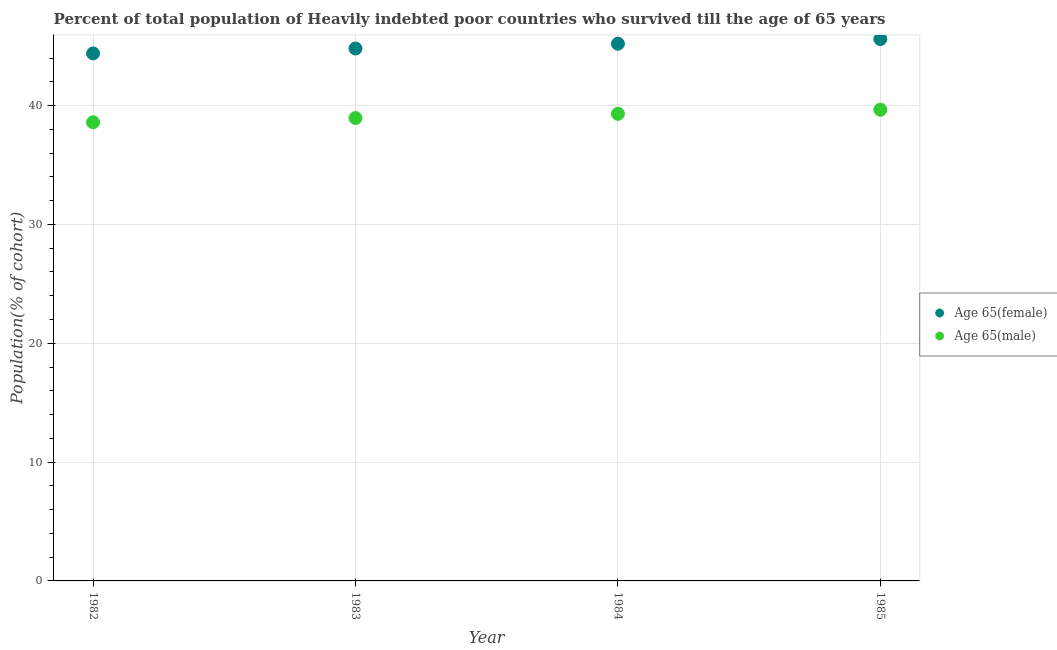How many different coloured dotlines are there?
Make the answer very short. 2. Is the number of dotlines equal to the number of legend labels?
Give a very brief answer. Yes. What is the percentage of male population who survived till age of 65 in 1982?
Ensure brevity in your answer.  38.6. Across all years, what is the maximum percentage of male population who survived till age of 65?
Offer a very short reply. 39.66. Across all years, what is the minimum percentage of male population who survived till age of 65?
Keep it short and to the point. 38.6. What is the total percentage of female population who survived till age of 65 in the graph?
Provide a short and direct response. 180.02. What is the difference between the percentage of female population who survived till age of 65 in 1983 and that in 1985?
Offer a very short reply. -0.8. What is the difference between the percentage of male population who survived till age of 65 in 1982 and the percentage of female population who survived till age of 65 in 1984?
Provide a succinct answer. -6.62. What is the average percentage of male population who survived till age of 65 per year?
Your response must be concise. 39.13. In the year 1982, what is the difference between the percentage of male population who survived till age of 65 and percentage of female population who survived till age of 65?
Your answer should be very brief. -5.8. In how many years, is the percentage of male population who survived till age of 65 greater than 16 %?
Your answer should be compact. 4. What is the ratio of the percentage of female population who survived till age of 65 in 1984 to that in 1985?
Offer a very short reply. 0.99. What is the difference between the highest and the second highest percentage of female population who survived till age of 65?
Provide a short and direct response. 0.39. What is the difference between the highest and the lowest percentage of male population who survived till age of 65?
Offer a very short reply. 1.06. In how many years, is the percentage of male population who survived till age of 65 greater than the average percentage of male population who survived till age of 65 taken over all years?
Ensure brevity in your answer.  2. Is the percentage of female population who survived till age of 65 strictly greater than the percentage of male population who survived till age of 65 over the years?
Ensure brevity in your answer.  Yes. Is the percentage of female population who survived till age of 65 strictly less than the percentage of male population who survived till age of 65 over the years?
Offer a terse response. No. How many dotlines are there?
Make the answer very short. 2. How many years are there in the graph?
Keep it short and to the point. 4. Where does the legend appear in the graph?
Your answer should be compact. Center right. How many legend labels are there?
Ensure brevity in your answer.  2. What is the title of the graph?
Make the answer very short. Percent of total population of Heavily indebted poor countries who survived till the age of 65 years. What is the label or title of the Y-axis?
Offer a terse response. Population(% of cohort). What is the Population(% of cohort) of Age 65(female) in 1982?
Give a very brief answer. 44.39. What is the Population(% of cohort) in Age 65(male) in 1982?
Give a very brief answer. 38.6. What is the Population(% of cohort) in Age 65(female) in 1983?
Give a very brief answer. 44.81. What is the Population(% of cohort) of Age 65(male) in 1983?
Make the answer very short. 38.96. What is the Population(% of cohort) in Age 65(female) in 1984?
Ensure brevity in your answer.  45.21. What is the Population(% of cohort) in Age 65(male) in 1984?
Offer a very short reply. 39.31. What is the Population(% of cohort) of Age 65(female) in 1985?
Provide a short and direct response. 45.6. What is the Population(% of cohort) of Age 65(male) in 1985?
Keep it short and to the point. 39.66. Across all years, what is the maximum Population(% of cohort) of Age 65(female)?
Keep it short and to the point. 45.6. Across all years, what is the maximum Population(% of cohort) in Age 65(male)?
Keep it short and to the point. 39.66. Across all years, what is the minimum Population(% of cohort) in Age 65(female)?
Provide a succinct answer. 44.39. Across all years, what is the minimum Population(% of cohort) in Age 65(male)?
Your answer should be very brief. 38.6. What is the total Population(% of cohort) of Age 65(female) in the graph?
Offer a terse response. 180.02. What is the total Population(% of cohort) of Age 65(male) in the graph?
Provide a short and direct response. 156.52. What is the difference between the Population(% of cohort) in Age 65(female) in 1982 and that in 1983?
Ensure brevity in your answer.  -0.41. What is the difference between the Population(% of cohort) in Age 65(male) in 1982 and that in 1983?
Give a very brief answer. -0.36. What is the difference between the Population(% of cohort) of Age 65(female) in 1982 and that in 1984?
Provide a succinct answer. -0.82. What is the difference between the Population(% of cohort) of Age 65(male) in 1982 and that in 1984?
Offer a terse response. -0.72. What is the difference between the Population(% of cohort) in Age 65(female) in 1982 and that in 1985?
Your answer should be very brief. -1.21. What is the difference between the Population(% of cohort) in Age 65(male) in 1982 and that in 1985?
Make the answer very short. -1.06. What is the difference between the Population(% of cohort) in Age 65(female) in 1983 and that in 1984?
Your response must be concise. -0.4. What is the difference between the Population(% of cohort) of Age 65(male) in 1983 and that in 1984?
Make the answer very short. -0.35. What is the difference between the Population(% of cohort) in Age 65(female) in 1983 and that in 1985?
Make the answer very short. -0.8. What is the difference between the Population(% of cohort) in Age 65(male) in 1983 and that in 1985?
Keep it short and to the point. -0.7. What is the difference between the Population(% of cohort) of Age 65(female) in 1984 and that in 1985?
Ensure brevity in your answer.  -0.39. What is the difference between the Population(% of cohort) of Age 65(male) in 1984 and that in 1985?
Ensure brevity in your answer.  -0.34. What is the difference between the Population(% of cohort) of Age 65(female) in 1982 and the Population(% of cohort) of Age 65(male) in 1983?
Offer a very short reply. 5.44. What is the difference between the Population(% of cohort) in Age 65(female) in 1982 and the Population(% of cohort) in Age 65(male) in 1984?
Offer a terse response. 5.08. What is the difference between the Population(% of cohort) in Age 65(female) in 1982 and the Population(% of cohort) in Age 65(male) in 1985?
Provide a succinct answer. 4.74. What is the difference between the Population(% of cohort) of Age 65(female) in 1983 and the Population(% of cohort) of Age 65(male) in 1984?
Offer a very short reply. 5.49. What is the difference between the Population(% of cohort) of Age 65(female) in 1983 and the Population(% of cohort) of Age 65(male) in 1985?
Offer a terse response. 5.15. What is the difference between the Population(% of cohort) of Age 65(female) in 1984 and the Population(% of cohort) of Age 65(male) in 1985?
Your response must be concise. 5.56. What is the average Population(% of cohort) of Age 65(female) per year?
Your answer should be very brief. 45. What is the average Population(% of cohort) in Age 65(male) per year?
Give a very brief answer. 39.13. In the year 1982, what is the difference between the Population(% of cohort) of Age 65(female) and Population(% of cohort) of Age 65(male)?
Your response must be concise. 5.8. In the year 1983, what is the difference between the Population(% of cohort) of Age 65(female) and Population(% of cohort) of Age 65(male)?
Make the answer very short. 5.85. In the year 1984, what is the difference between the Population(% of cohort) in Age 65(female) and Population(% of cohort) in Age 65(male)?
Offer a very short reply. 5.9. In the year 1985, what is the difference between the Population(% of cohort) of Age 65(female) and Population(% of cohort) of Age 65(male)?
Provide a succinct answer. 5.95. What is the ratio of the Population(% of cohort) in Age 65(female) in 1982 to that in 1984?
Ensure brevity in your answer.  0.98. What is the ratio of the Population(% of cohort) in Age 65(male) in 1982 to that in 1984?
Make the answer very short. 0.98. What is the ratio of the Population(% of cohort) of Age 65(female) in 1982 to that in 1985?
Make the answer very short. 0.97. What is the ratio of the Population(% of cohort) of Age 65(male) in 1982 to that in 1985?
Give a very brief answer. 0.97. What is the ratio of the Population(% of cohort) of Age 65(male) in 1983 to that in 1984?
Offer a very short reply. 0.99. What is the ratio of the Population(% of cohort) in Age 65(female) in 1983 to that in 1985?
Ensure brevity in your answer.  0.98. What is the ratio of the Population(% of cohort) in Age 65(male) in 1983 to that in 1985?
Provide a short and direct response. 0.98. What is the difference between the highest and the second highest Population(% of cohort) of Age 65(female)?
Offer a very short reply. 0.39. What is the difference between the highest and the second highest Population(% of cohort) of Age 65(male)?
Your answer should be very brief. 0.34. What is the difference between the highest and the lowest Population(% of cohort) of Age 65(female)?
Keep it short and to the point. 1.21. What is the difference between the highest and the lowest Population(% of cohort) in Age 65(male)?
Make the answer very short. 1.06. 